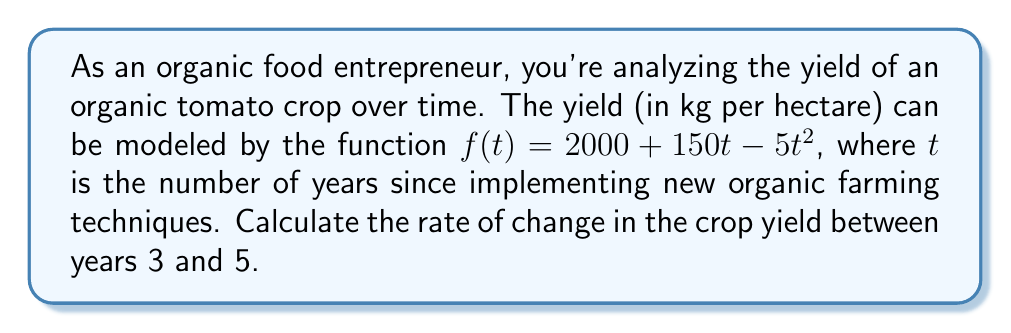Show me your answer to this math problem. To find the rate of change between two points, we need to use the average rate of change formula:

$$ \text{Average rate of change} = \frac{f(b) - f(a)}{b - a} $$

Where $a$ and $b$ are the two points in time we're considering.

1) First, let's calculate $f(3)$ and $f(5)$:

   $f(3) = 2000 + 150(3) - 5(3)^2$
   $f(3) = 2000 + 450 - 45 = 2405$ kg/hectare

   $f(5) = 2000 + 150(5) - 5(5)^2$
   $f(5) = 2000 + 750 - 125 = 2625$ kg/hectare

2) Now we can plug these values into our rate of change formula:

   $$ \text{Rate of change} = \frac{f(5) - f(3)}{5 - 3} = \frac{2625 - 2405}{2} = \frac{220}{2} = 110 $$

Therefore, the rate of change in crop yield between years 3 and 5 is 110 kg per hectare per year.
Answer: 110 kg/hectare/year 